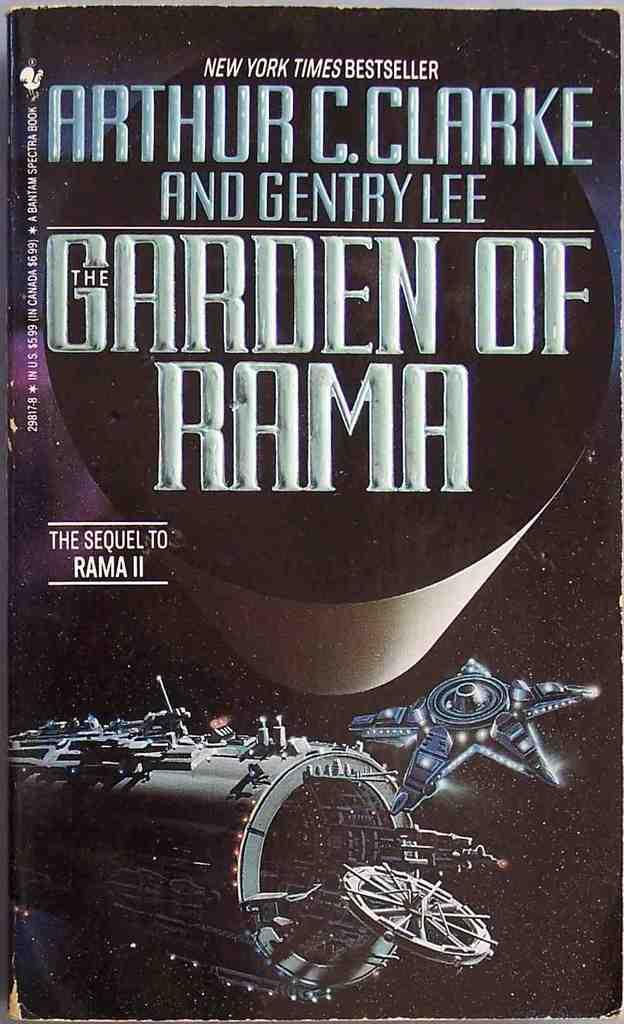<image>
Write a terse but informative summary of the picture. An Arthur C. Clarke book called Garden of Rama. 